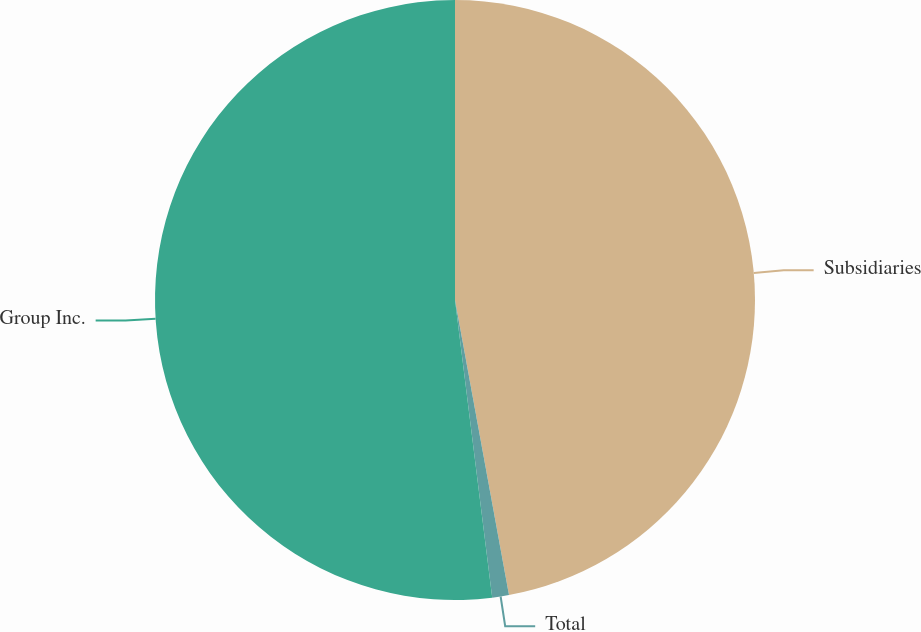Convert chart to OTSL. <chart><loc_0><loc_0><loc_500><loc_500><pie_chart><fcel>Subsidiaries<fcel>Total<fcel>Group Inc.<nl><fcel>47.12%<fcel>0.9%<fcel>51.98%<nl></chart> 